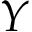<formula> <loc_0><loc_0><loc_500><loc_500>Y</formula> 